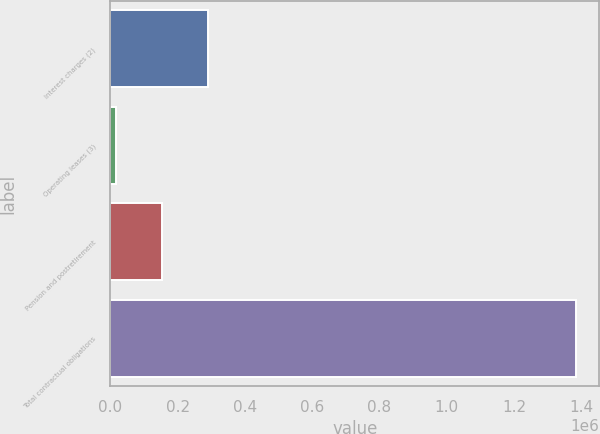Convert chart. <chart><loc_0><loc_0><loc_500><loc_500><bar_chart><fcel>Interest charges (2)<fcel>Operating leases (3)<fcel>Pension and postretirement<fcel>Total contractual obligations<nl><fcel>290980<fcel>17655<fcel>154317<fcel>1.38428e+06<nl></chart> 